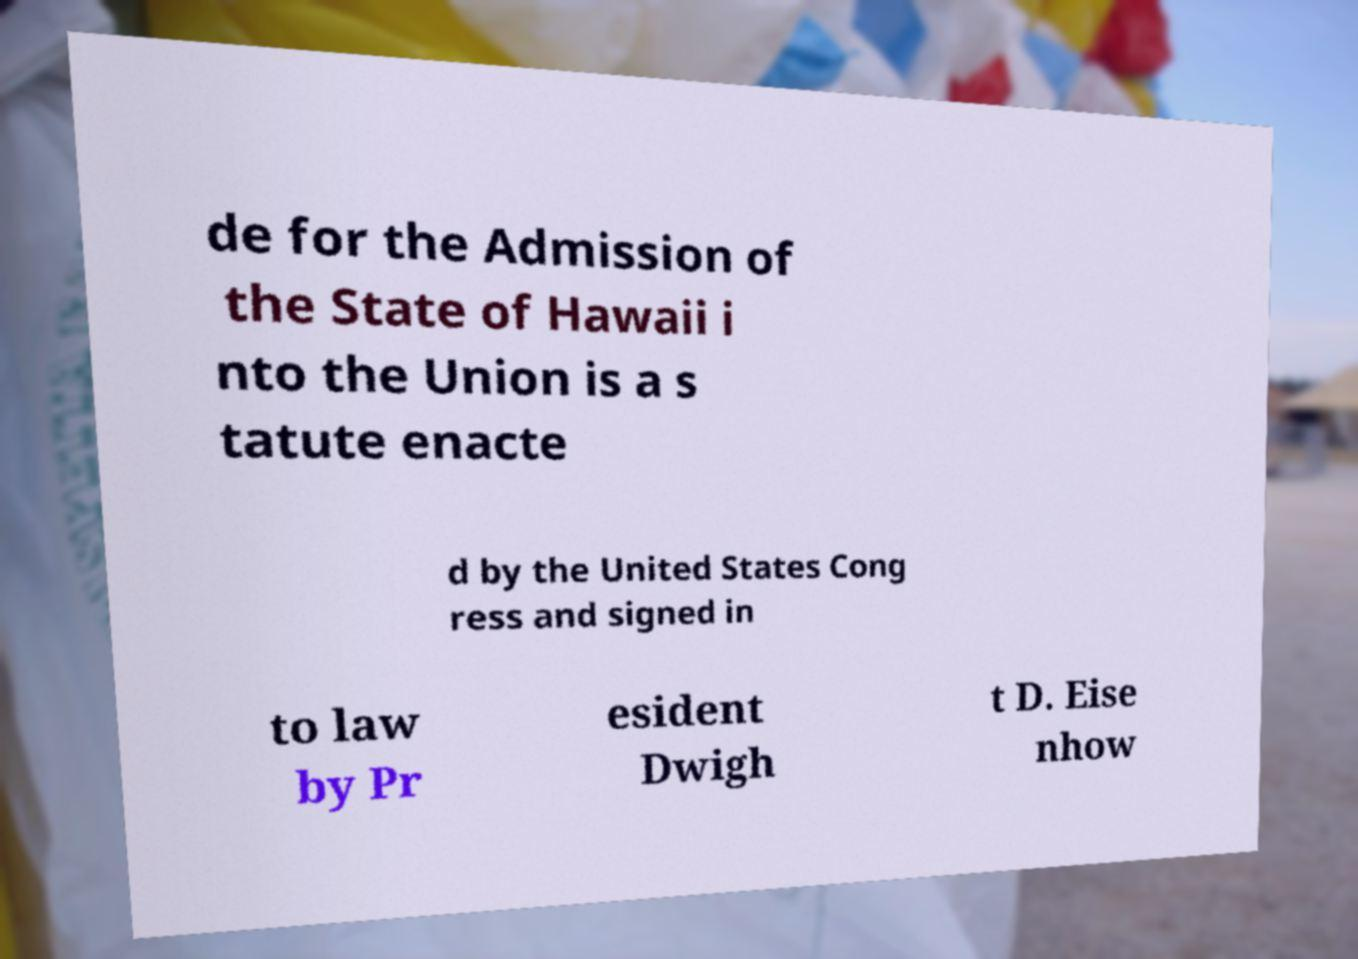I need the written content from this picture converted into text. Can you do that? de for the Admission of the State of Hawaii i nto the Union is a s tatute enacte d by the United States Cong ress and signed in to law by Pr esident Dwigh t D. Eise nhow 